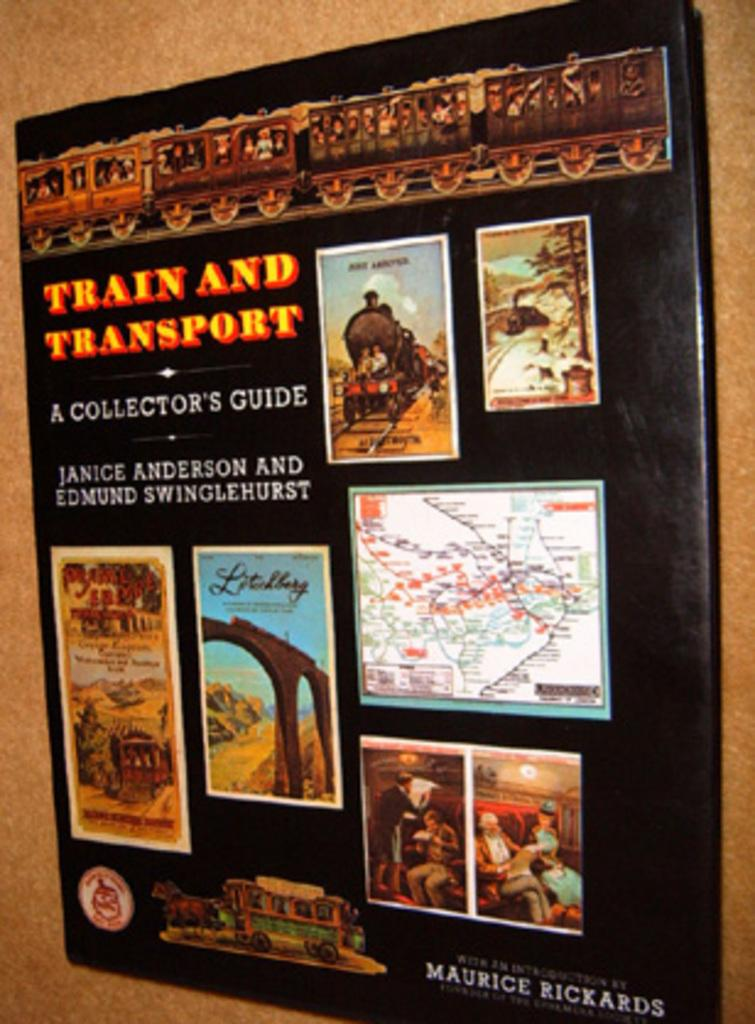<image>
Create a compact narrative representing the image presented. A large sign with travel photographs says Train and Transport. 